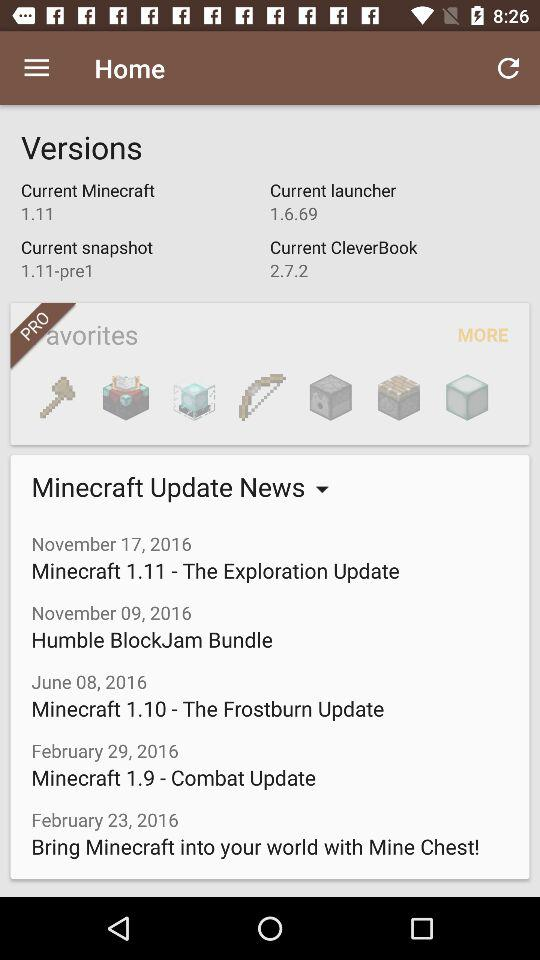When was the news about Minecraft 1.9 updated? The news was updated on February 29, 2016. 